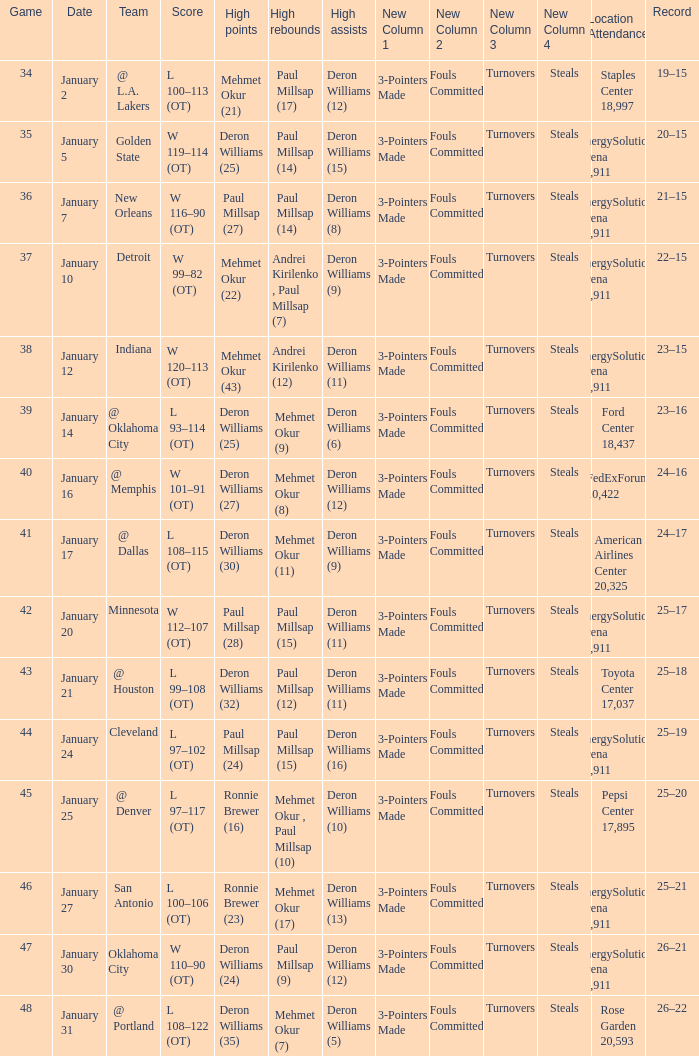Could you help me parse every detail presented in this table? {'header': ['Game', 'Date', 'Team', 'Score', 'High points', 'High rebounds', 'High assists', 'New Column 1', 'New Column 2', 'New Column 3', 'New Column 4', 'Location Attendance', 'Record'], 'rows': [['34', 'January 2', '@ L.A. Lakers', 'L 100–113 (OT)', 'Mehmet Okur (21)', 'Paul Millsap (17)', 'Deron Williams (12)', '3-Pointers Made', 'Fouls Committed', 'Turnovers', 'Steals', 'Staples Center 18,997', '19–15'], ['35', 'January 5', 'Golden State', 'W 119–114 (OT)', 'Deron Williams (25)', 'Paul Millsap (14)', 'Deron Williams (15)', '3-Pointers Made', 'Fouls Committed', 'Turnovers', 'Steals', 'EnergySolutions Arena 19,911', '20–15'], ['36', 'January 7', 'New Orleans', 'W 116–90 (OT)', 'Paul Millsap (27)', 'Paul Millsap (14)', 'Deron Williams (8)', '3-Pointers Made', 'Fouls Committed', 'Turnovers', 'Steals', 'EnergySolutions Arena 19,911', '21–15'], ['37', 'January 10', 'Detroit', 'W 99–82 (OT)', 'Mehmet Okur (22)', 'Andrei Kirilenko , Paul Millsap (7)', 'Deron Williams (9)', '3-Pointers Made', 'Fouls Committed', 'Turnovers', 'Steals', 'EnergySolutions Arena 19,911', '22–15'], ['38', 'January 12', 'Indiana', 'W 120–113 (OT)', 'Mehmet Okur (43)', 'Andrei Kirilenko (12)', 'Deron Williams (11)', '3-Pointers Made', 'Fouls Committed', 'Turnovers', 'Steals', 'EnergySolutions Arena 19,911', '23–15'], ['39', 'January 14', '@ Oklahoma City', 'L 93–114 (OT)', 'Deron Williams (25)', 'Mehmet Okur (9)', 'Deron Williams (6)', '3-Pointers Made', 'Fouls Committed', 'Turnovers', 'Steals', 'Ford Center 18,437', '23–16'], ['40', 'January 16', '@ Memphis', 'W 101–91 (OT)', 'Deron Williams (27)', 'Mehmet Okur (8)', 'Deron Williams (12)', '3-Pointers Made', 'Fouls Committed', 'Turnovers', 'Steals', 'FedExForum 10,422', '24–16'], ['41', 'January 17', '@ Dallas', 'L 108–115 (OT)', 'Deron Williams (30)', 'Mehmet Okur (11)', 'Deron Williams (9)', '3-Pointers Made', 'Fouls Committed', 'Turnovers', 'Steals', 'American Airlines Center 20,325', '24–17'], ['42', 'January 20', 'Minnesota', 'W 112–107 (OT)', 'Paul Millsap (28)', 'Paul Millsap (15)', 'Deron Williams (11)', '3-Pointers Made', 'Fouls Committed', 'Turnovers', 'Steals', 'EnergySolutions Arena 19,911', '25–17'], ['43', 'January 21', '@ Houston', 'L 99–108 (OT)', 'Deron Williams (32)', 'Paul Millsap (12)', 'Deron Williams (11)', '3-Pointers Made', 'Fouls Committed', 'Turnovers', 'Steals', 'Toyota Center 17,037', '25–18'], ['44', 'January 24', 'Cleveland', 'L 97–102 (OT)', 'Paul Millsap (24)', 'Paul Millsap (15)', 'Deron Williams (16)', '3-Pointers Made', 'Fouls Committed', 'Turnovers', 'Steals', 'EnergySolutions Arena 19,911', '25–19'], ['45', 'January 25', '@ Denver', 'L 97–117 (OT)', 'Ronnie Brewer (16)', 'Mehmet Okur , Paul Millsap (10)', 'Deron Williams (10)', '3-Pointers Made', 'Fouls Committed', 'Turnovers', 'Steals', 'Pepsi Center 17,895', '25–20'], ['46', 'January 27', 'San Antonio', 'L 100–106 (OT)', 'Ronnie Brewer (23)', 'Mehmet Okur (17)', 'Deron Williams (13)', '3-Pointers Made', 'Fouls Committed', 'Turnovers', 'Steals', 'EnergySolutions Arena 19,911', '25–21'], ['47', 'January 30', 'Oklahoma City', 'W 110–90 (OT)', 'Deron Williams (24)', 'Paul Millsap (9)', 'Deron Williams (12)', '3-Pointers Made', 'Fouls Committed', 'Turnovers', 'Steals', 'EnergySolutions Arena 19,911', '26–21'], ['48', 'January 31', '@ Portland', 'L 108–122 (OT)', 'Deron Williams (35)', 'Mehmet Okur (7)', 'Deron Williams (5)', '3-Pointers Made', 'Fouls Committed', 'Turnovers', 'Steals', 'Rose Garden 20,593', '26–22']]} Who had the high rebounds of the game that Deron Williams (5) had the high assists? Mehmet Okur (7). 